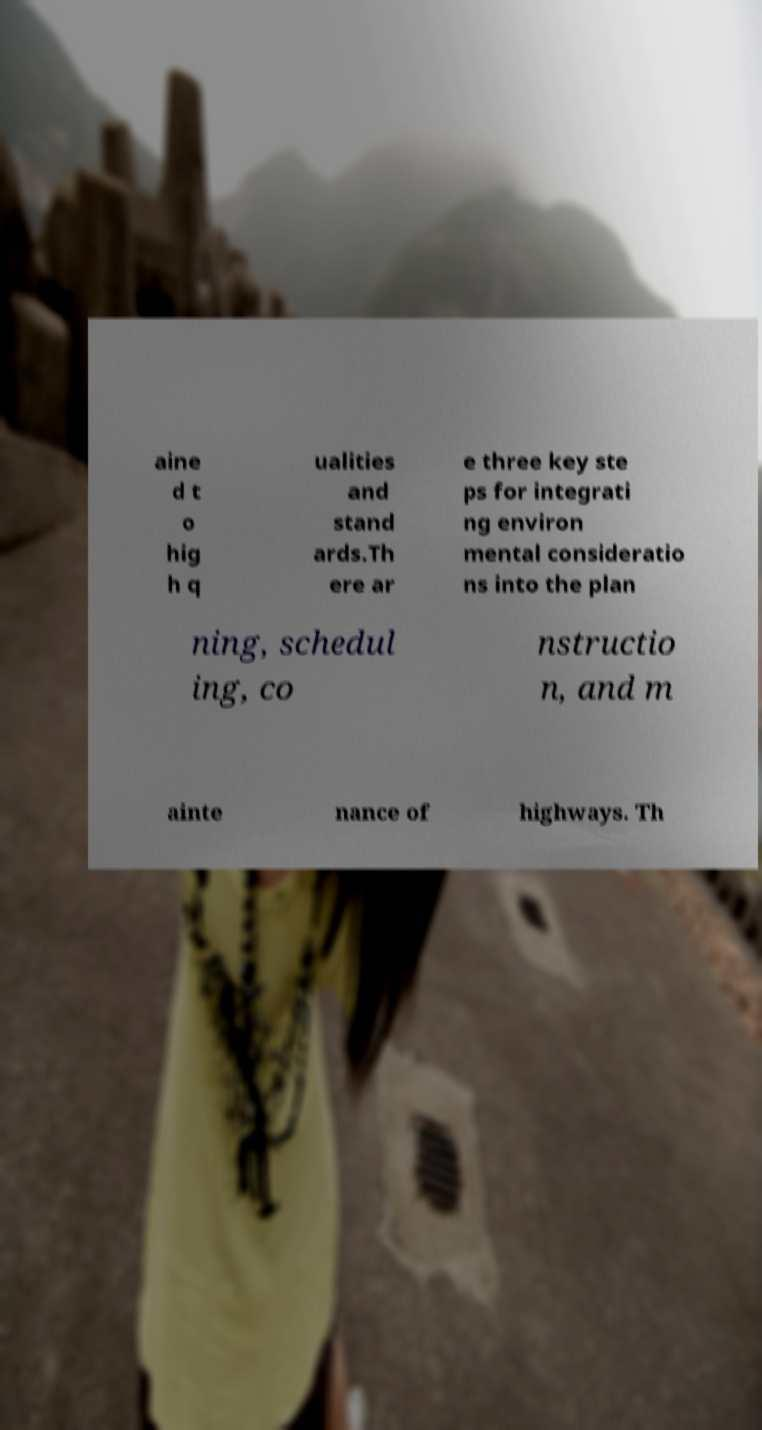There's text embedded in this image that I need extracted. Can you transcribe it verbatim? aine d t o hig h q ualities and stand ards.Th ere ar e three key ste ps for integrati ng environ mental consideratio ns into the plan ning, schedul ing, co nstructio n, and m ainte nance of highways. Th 